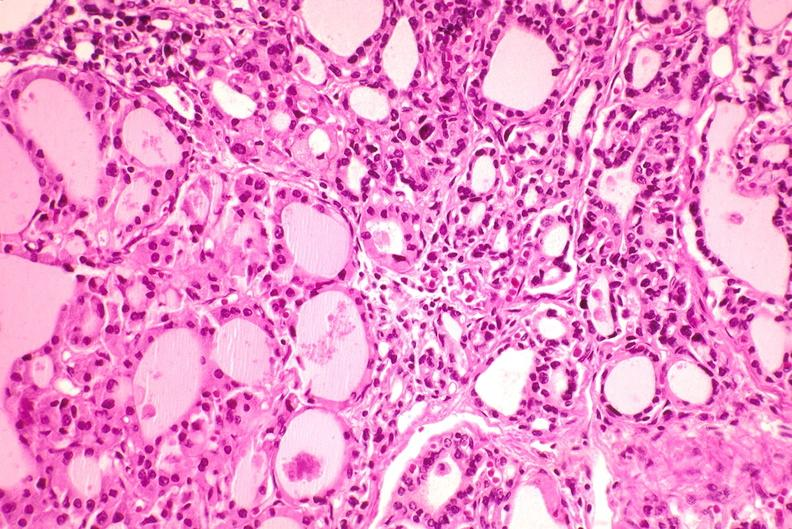where is this part in the figure?
Answer the question using a single word or phrase. Endocrine system 